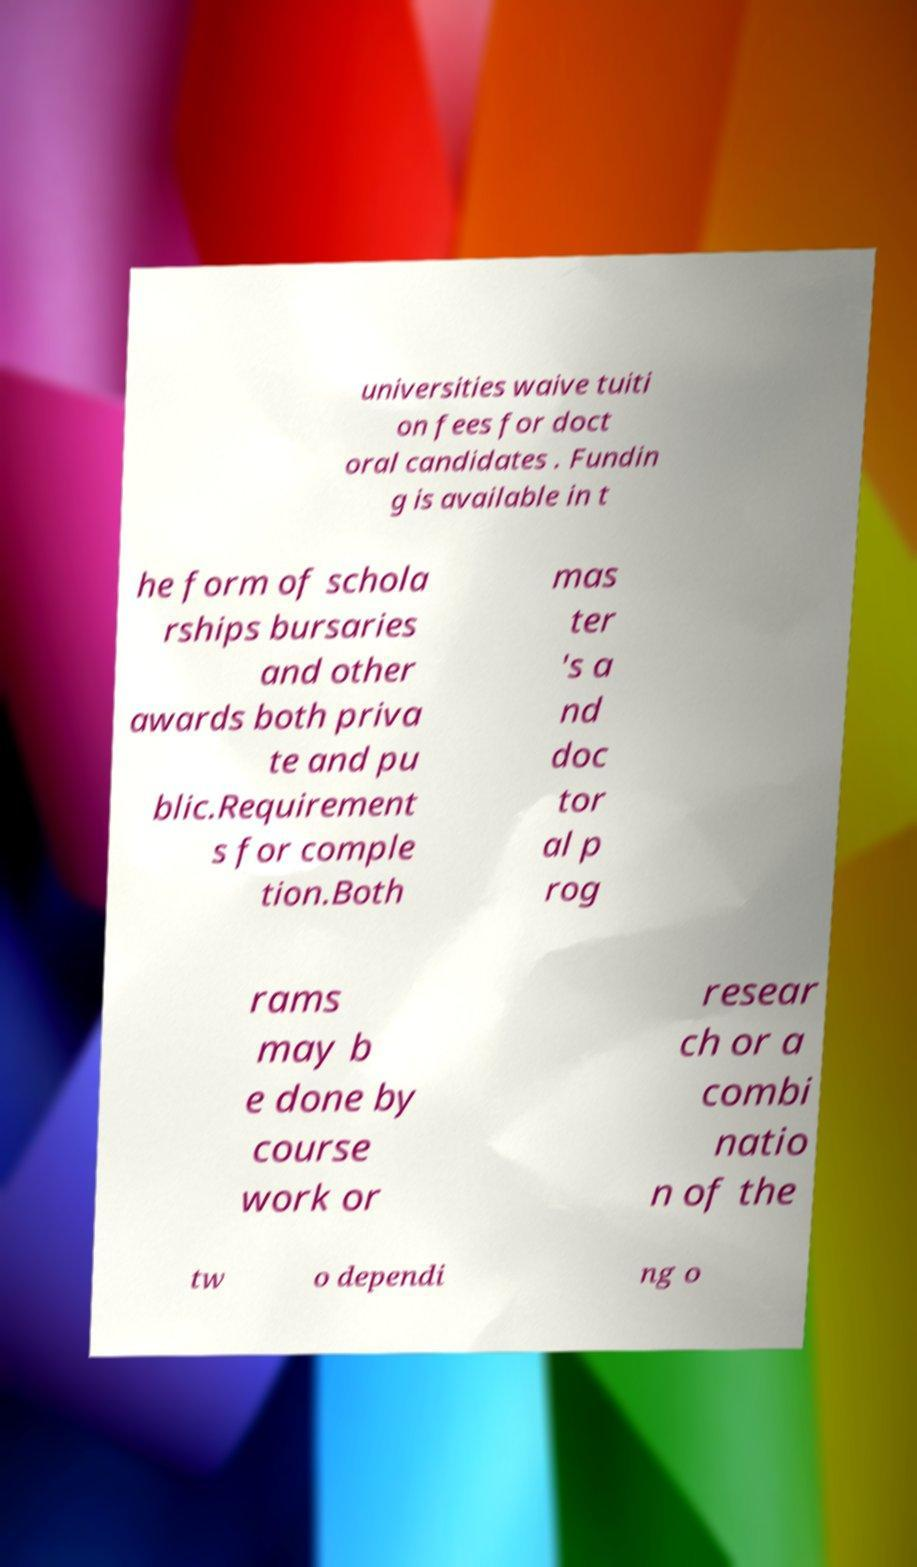Please identify and transcribe the text found in this image. universities waive tuiti on fees for doct oral candidates . Fundin g is available in t he form of schola rships bursaries and other awards both priva te and pu blic.Requirement s for comple tion.Both mas ter 's a nd doc tor al p rog rams may b e done by course work or resear ch or a combi natio n of the tw o dependi ng o 